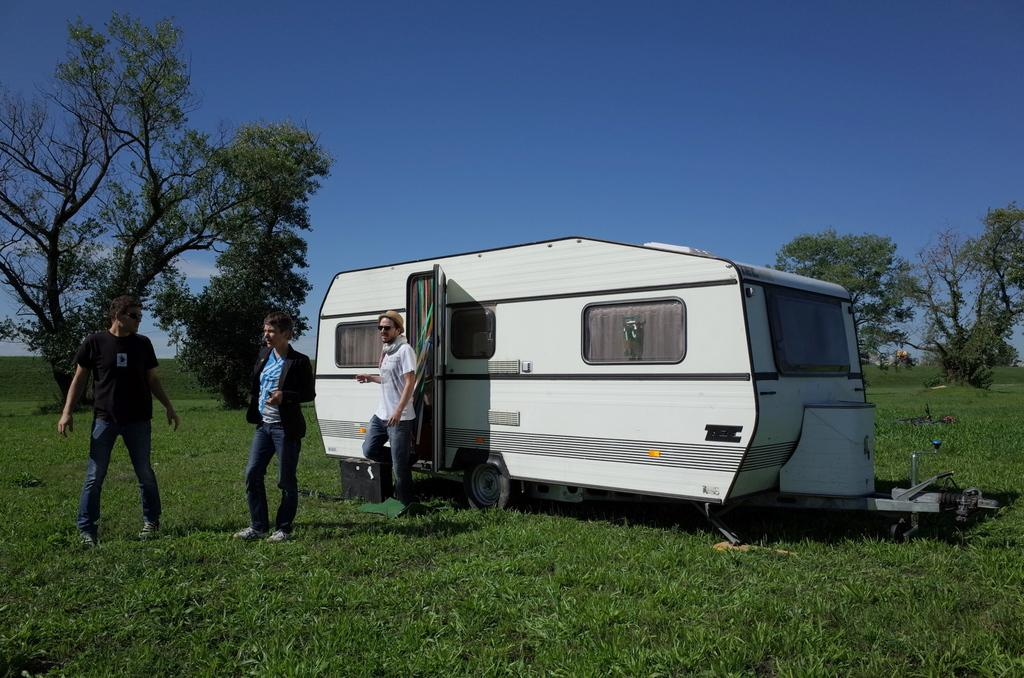How many people are in the image? There are three persons in the image. What is the position of the persons in the image? The persons are on the ground. What is located near the persons in the image? The persons are near a vehicle. What can be seen in the background of the image? There are trees and the sky visible in the background of the image. What type of turkey can be seen in the image? There is no turkey present in the image. What suggestion is being made by the persons in the image? The image does not provide any information about a suggestion being made by the persons. 